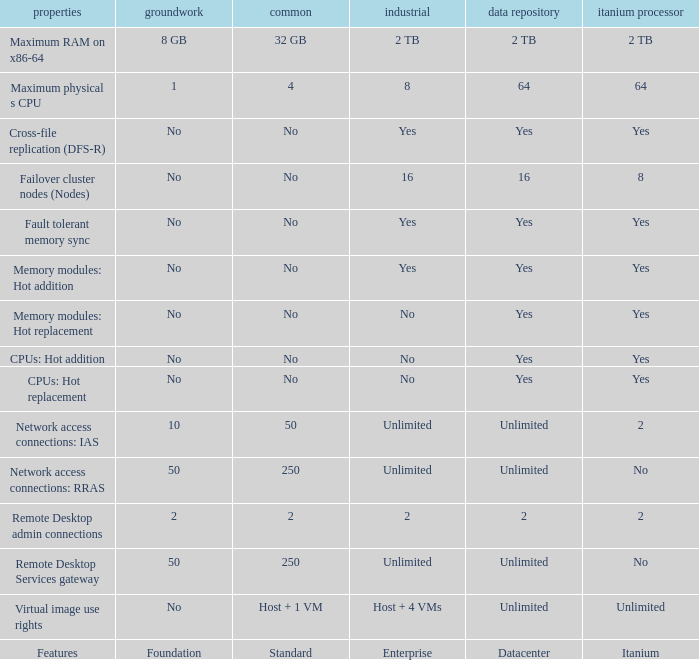What is the Enterprise for teh memory modules: hot replacement Feature that has a Datacenter of Yes? No. 